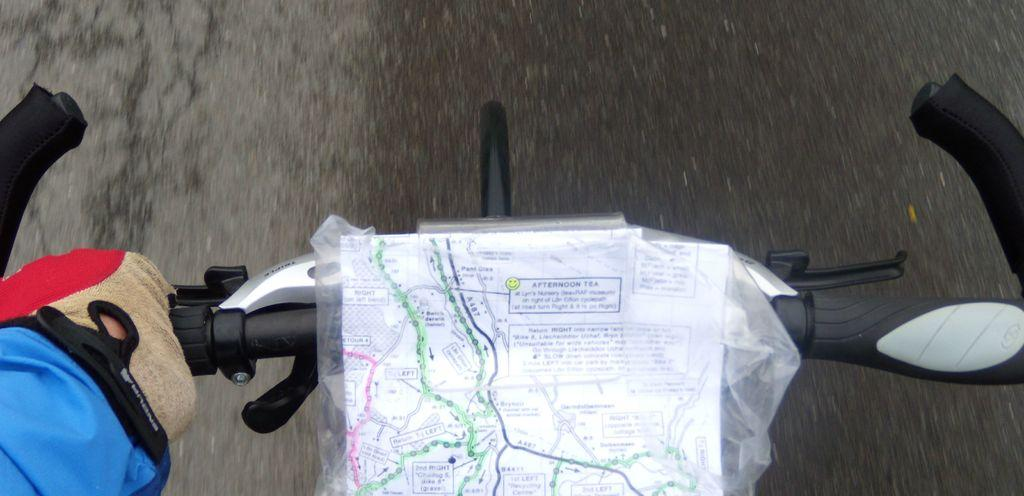What type of map is visible in the image? There is a route map in the image. What is the person's hand doing in the image? The person's hand is holding a bicycle. Where is the bicycle located in the image? The bicycle is on the road. What type of hat is the person wearing in the image? There is no hat visible in the image; the person's hand is holding a bicycle. Can you see an airplane in the image? No, there is no airplane present in the image. 